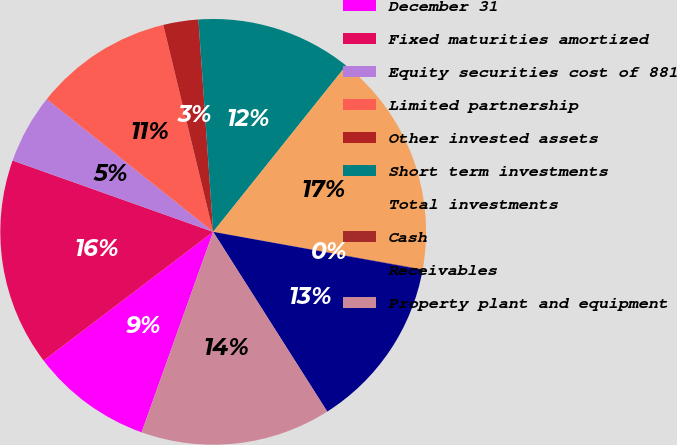Convert chart. <chart><loc_0><loc_0><loc_500><loc_500><pie_chart><fcel>December 31<fcel>Fixed maturities amortized<fcel>Equity securities cost of 881<fcel>Limited partnership<fcel>Other invested assets<fcel>Short term investments<fcel>Total investments<fcel>Cash<fcel>Receivables<fcel>Property plant and equipment<nl><fcel>9.21%<fcel>15.77%<fcel>5.28%<fcel>10.52%<fcel>2.66%<fcel>11.84%<fcel>17.08%<fcel>0.04%<fcel>13.15%<fcel>14.46%<nl></chart> 